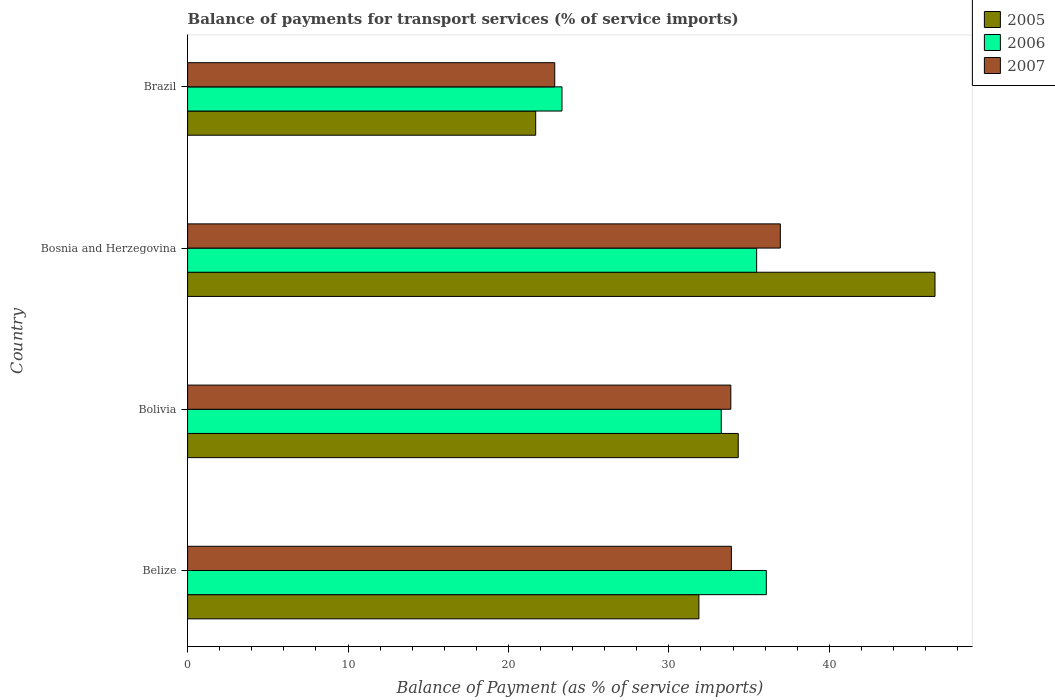How many different coloured bars are there?
Your answer should be compact. 3. Are the number of bars on each tick of the Y-axis equal?
Offer a terse response. Yes. In how many cases, is the number of bars for a given country not equal to the number of legend labels?
Provide a short and direct response. 0. What is the balance of payments for transport services in 2007 in Bosnia and Herzegovina?
Give a very brief answer. 36.95. Across all countries, what is the maximum balance of payments for transport services in 2006?
Ensure brevity in your answer.  36.07. Across all countries, what is the minimum balance of payments for transport services in 2006?
Your response must be concise. 23.34. In which country was the balance of payments for transport services in 2007 maximum?
Your response must be concise. Bosnia and Herzegovina. In which country was the balance of payments for transport services in 2005 minimum?
Offer a very short reply. Brazil. What is the total balance of payments for transport services in 2007 in the graph?
Keep it short and to the point. 127.59. What is the difference between the balance of payments for transport services in 2006 in Belize and that in Bolivia?
Give a very brief answer. 2.81. What is the difference between the balance of payments for transport services in 2007 in Bosnia and Herzegovina and the balance of payments for transport services in 2005 in Brazil?
Provide a short and direct response. 15.25. What is the average balance of payments for transport services in 2007 per country?
Provide a succinct answer. 31.9. What is the difference between the balance of payments for transport services in 2005 and balance of payments for transport services in 2006 in Belize?
Provide a short and direct response. -4.2. What is the ratio of the balance of payments for transport services in 2006 in Belize to that in Bosnia and Herzegovina?
Provide a succinct answer. 1.02. Is the balance of payments for transport services in 2005 in Bolivia less than that in Bosnia and Herzegovina?
Give a very brief answer. Yes. What is the difference between the highest and the second highest balance of payments for transport services in 2006?
Ensure brevity in your answer.  0.6. What is the difference between the highest and the lowest balance of payments for transport services in 2005?
Offer a terse response. 24.89. What does the 2nd bar from the bottom in Bosnia and Herzegovina represents?
Your answer should be very brief. 2006. Is it the case that in every country, the sum of the balance of payments for transport services in 2006 and balance of payments for transport services in 2005 is greater than the balance of payments for transport services in 2007?
Offer a terse response. Yes. How many bars are there?
Offer a terse response. 12. Are the values on the major ticks of X-axis written in scientific E-notation?
Keep it short and to the point. No. Where does the legend appear in the graph?
Make the answer very short. Top right. What is the title of the graph?
Give a very brief answer. Balance of payments for transport services (% of service imports). Does "2014" appear as one of the legend labels in the graph?
Provide a succinct answer. No. What is the label or title of the X-axis?
Offer a terse response. Balance of Payment (as % of service imports). What is the label or title of the Y-axis?
Give a very brief answer. Country. What is the Balance of Payment (as % of service imports) in 2005 in Belize?
Your answer should be compact. 31.87. What is the Balance of Payment (as % of service imports) in 2006 in Belize?
Your response must be concise. 36.07. What is the Balance of Payment (as % of service imports) of 2007 in Belize?
Your answer should be compact. 33.89. What is the Balance of Payment (as % of service imports) of 2005 in Bolivia?
Give a very brief answer. 34.32. What is the Balance of Payment (as % of service imports) in 2006 in Bolivia?
Offer a very short reply. 33.26. What is the Balance of Payment (as % of service imports) in 2007 in Bolivia?
Your response must be concise. 33.86. What is the Balance of Payment (as % of service imports) in 2005 in Bosnia and Herzegovina?
Your answer should be compact. 46.59. What is the Balance of Payment (as % of service imports) in 2006 in Bosnia and Herzegovina?
Your response must be concise. 35.47. What is the Balance of Payment (as % of service imports) in 2007 in Bosnia and Herzegovina?
Ensure brevity in your answer.  36.95. What is the Balance of Payment (as % of service imports) of 2005 in Brazil?
Your response must be concise. 21.7. What is the Balance of Payment (as % of service imports) of 2006 in Brazil?
Your answer should be very brief. 23.34. What is the Balance of Payment (as % of service imports) in 2007 in Brazil?
Make the answer very short. 22.89. Across all countries, what is the maximum Balance of Payment (as % of service imports) in 2005?
Provide a short and direct response. 46.59. Across all countries, what is the maximum Balance of Payment (as % of service imports) in 2006?
Your answer should be compact. 36.07. Across all countries, what is the maximum Balance of Payment (as % of service imports) in 2007?
Your response must be concise. 36.95. Across all countries, what is the minimum Balance of Payment (as % of service imports) of 2005?
Provide a short and direct response. 21.7. Across all countries, what is the minimum Balance of Payment (as % of service imports) in 2006?
Provide a succinct answer. 23.34. Across all countries, what is the minimum Balance of Payment (as % of service imports) of 2007?
Ensure brevity in your answer.  22.89. What is the total Balance of Payment (as % of service imports) in 2005 in the graph?
Your answer should be very brief. 134.48. What is the total Balance of Payment (as % of service imports) of 2006 in the graph?
Give a very brief answer. 128.14. What is the total Balance of Payment (as % of service imports) of 2007 in the graph?
Provide a succinct answer. 127.59. What is the difference between the Balance of Payment (as % of service imports) in 2005 in Belize and that in Bolivia?
Make the answer very short. -2.45. What is the difference between the Balance of Payment (as % of service imports) of 2006 in Belize and that in Bolivia?
Provide a short and direct response. 2.81. What is the difference between the Balance of Payment (as % of service imports) of 2007 in Belize and that in Bolivia?
Your response must be concise. 0.03. What is the difference between the Balance of Payment (as % of service imports) in 2005 in Belize and that in Bosnia and Herzegovina?
Ensure brevity in your answer.  -14.72. What is the difference between the Balance of Payment (as % of service imports) of 2006 in Belize and that in Bosnia and Herzegovina?
Provide a succinct answer. 0.6. What is the difference between the Balance of Payment (as % of service imports) in 2007 in Belize and that in Bosnia and Herzegovina?
Your answer should be compact. -3.05. What is the difference between the Balance of Payment (as % of service imports) in 2005 in Belize and that in Brazil?
Give a very brief answer. 10.17. What is the difference between the Balance of Payment (as % of service imports) in 2006 in Belize and that in Brazil?
Provide a short and direct response. 12.74. What is the difference between the Balance of Payment (as % of service imports) in 2007 in Belize and that in Brazil?
Keep it short and to the point. 11.01. What is the difference between the Balance of Payment (as % of service imports) in 2005 in Bolivia and that in Bosnia and Herzegovina?
Your answer should be very brief. -12.26. What is the difference between the Balance of Payment (as % of service imports) of 2006 in Bolivia and that in Bosnia and Herzegovina?
Keep it short and to the point. -2.21. What is the difference between the Balance of Payment (as % of service imports) of 2007 in Bolivia and that in Bosnia and Herzegovina?
Provide a short and direct response. -3.09. What is the difference between the Balance of Payment (as % of service imports) in 2005 in Bolivia and that in Brazil?
Offer a terse response. 12.63. What is the difference between the Balance of Payment (as % of service imports) of 2006 in Bolivia and that in Brazil?
Your response must be concise. 9.93. What is the difference between the Balance of Payment (as % of service imports) of 2007 in Bolivia and that in Brazil?
Your answer should be compact. 10.98. What is the difference between the Balance of Payment (as % of service imports) of 2005 in Bosnia and Herzegovina and that in Brazil?
Give a very brief answer. 24.89. What is the difference between the Balance of Payment (as % of service imports) of 2006 in Bosnia and Herzegovina and that in Brazil?
Provide a succinct answer. 12.13. What is the difference between the Balance of Payment (as % of service imports) in 2007 in Bosnia and Herzegovina and that in Brazil?
Offer a very short reply. 14.06. What is the difference between the Balance of Payment (as % of service imports) in 2005 in Belize and the Balance of Payment (as % of service imports) in 2006 in Bolivia?
Provide a succinct answer. -1.39. What is the difference between the Balance of Payment (as % of service imports) of 2005 in Belize and the Balance of Payment (as % of service imports) of 2007 in Bolivia?
Make the answer very short. -1.99. What is the difference between the Balance of Payment (as % of service imports) of 2006 in Belize and the Balance of Payment (as % of service imports) of 2007 in Bolivia?
Offer a very short reply. 2.21. What is the difference between the Balance of Payment (as % of service imports) of 2005 in Belize and the Balance of Payment (as % of service imports) of 2006 in Bosnia and Herzegovina?
Provide a succinct answer. -3.6. What is the difference between the Balance of Payment (as % of service imports) in 2005 in Belize and the Balance of Payment (as % of service imports) in 2007 in Bosnia and Herzegovina?
Your answer should be very brief. -5.08. What is the difference between the Balance of Payment (as % of service imports) of 2006 in Belize and the Balance of Payment (as % of service imports) of 2007 in Bosnia and Herzegovina?
Give a very brief answer. -0.87. What is the difference between the Balance of Payment (as % of service imports) of 2005 in Belize and the Balance of Payment (as % of service imports) of 2006 in Brazil?
Offer a very short reply. 8.53. What is the difference between the Balance of Payment (as % of service imports) of 2005 in Belize and the Balance of Payment (as % of service imports) of 2007 in Brazil?
Provide a succinct answer. 8.99. What is the difference between the Balance of Payment (as % of service imports) of 2006 in Belize and the Balance of Payment (as % of service imports) of 2007 in Brazil?
Provide a short and direct response. 13.19. What is the difference between the Balance of Payment (as % of service imports) in 2005 in Bolivia and the Balance of Payment (as % of service imports) in 2006 in Bosnia and Herzegovina?
Your answer should be very brief. -1.15. What is the difference between the Balance of Payment (as % of service imports) of 2005 in Bolivia and the Balance of Payment (as % of service imports) of 2007 in Bosnia and Herzegovina?
Provide a succinct answer. -2.62. What is the difference between the Balance of Payment (as % of service imports) in 2006 in Bolivia and the Balance of Payment (as % of service imports) in 2007 in Bosnia and Herzegovina?
Ensure brevity in your answer.  -3.68. What is the difference between the Balance of Payment (as % of service imports) in 2005 in Bolivia and the Balance of Payment (as % of service imports) in 2006 in Brazil?
Your response must be concise. 10.99. What is the difference between the Balance of Payment (as % of service imports) in 2005 in Bolivia and the Balance of Payment (as % of service imports) in 2007 in Brazil?
Make the answer very short. 11.44. What is the difference between the Balance of Payment (as % of service imports) of 2006 in Bolivia and the Balance of Payment (as % of service imports) of 2007 in Brazil?
Make the answer very short. 10.38. What is the difference between the Balance of Payment (as % of service imports) in 2005 in Bosnia and Herzegovina and the Balance of Payment (as % of service imports) in 2006 in Brazil?
Keep it short and to the point. 23.25. What is the difference between the Balance of Payment (as % of service imports) of 2005 in Bosnia and Herzegovina and the Balance of Payment (as % of service imports) of 2007 in Brazil?
Your answer should be compact. 23.7. What is the difference between the Balance of Payment (as % of service imports) in 2006 in Bosnia and Herzegovina and the Balance of Payment (as % of service imports) in 2007 in Brazil?
Provide a succinct answer. 12.58. What is the average Balance of Payment (as % of service imports) of 2005 per country?
Offer a very short reply. 33.62. What is the average Balance of Payment (as % of service imports) of 2006 per country?
Ensure brevity in your answer.  32.04. What is the average Balance of Payment (as % of service imports) in 2007 per country?
Your response must be concise. 31.9. What is the difference between the Balance of Payment (as % of service imports) in 2005 and Balance of Payment (as % of service imports) in 2006 in Belize?
Make the answer very short. -4.2. What is the difference between the Balance of Payment (as % of service imports) of 2005 and Balance of Payment (as % of service imports) of 2007 in Belize?
Offer a very short reply. -2.02. What is the difference between the Balance of Payment (as % of service imports) of 2006 and Balance of Payment (as % of service imports) of 2007 in Belize?
Provide a short and direct response. 2.18. What is the difference between the Balance of Payment (as % of service imports) in 2005 and Balance of Payment (as % of service imports) in 2006 in Bolivia?
Provide a short and direct response. 1.06. What is the difference between the Balance of Payment (as % of service imports) of 2005 and Balance of Payment (as % of service imports) of 2007 in Bolivia?
Ensure brevity in your answer.  0.46. What is the difference between the Balance of Payment (as % of service imports) of 2006 and Balance of Payment (as % of service imports) of 2007 in Bolivia?
Offer a very short reply. -0.6. What is the difference between the Balance of Payment (as % of service imports) of 2005 and Balance of Payment (as % of service imports) of 2006 in Bosnia and Herzegovina?
Your answer should be compact. 11.12. What is the difference between the Balance of Payment (as % of service imports) of 2005 and Balance of Payment (as % of service imports) of 2007 in Bosnia and Herzegovina?
Your answer should be very brief. 9.64. What is the difference between the Balance of Payment (as % of service imports) of 2006 and Balance of Payment (as % of service imports) of 2007 in Bosnia and Herzegovina?
Your answer should be very brief. -1.48. What is the difference between the Balance of Payment (as % of service imports) in 2005 and Balance of Payment (as % of service imports) in 2006 in Brazil?
Provide a succinct answer. -1.64. What is the difference between the Balance of Payment (as % of service imports) of 2005 and Balance of Payment (as % of service imports) of 2007 in Brazil?
Your response must be concise. -1.19. What is the difference between the Balance of Payment (as % of service imports) in 2006 and Balance of Payment (as % of service imports) in 2007 in Brazil?
Your answer should be compact. 0.45. What is the ratio of the Balance of Payment (as % of service imports) in 2005 in Belize to that in Bolivia?
Your answer should be compact. 0.93. What is the ratio of the Balance of Payment (as % of service imports) in 2006 in Belize to that in Bolivia?
Make the answer very short. 1.08. What is the ratio of the Balance of Payment (as % of service imports) in 2007 in Belize to that in Bolivia?
Offer a terse response. 1. What is the ratio of the Balance of Payment (as % of service imports) of 2005 in Belize to that in Bosnia and Herzegovina?
Your answer should be very brief. 0.68. What is the ratio of the Balance of Payment (as % of service imports) of 2007 in Belize to that in Bosnia and Herzegovina?
Provide a succinct answer. 0.92. What is the ratio of the Balance of Payment (as % of service imports) of 2005 in Belize to that in Brazil?
Offer a very short reply. 1.47. What is the ratio of the Balance of Payment (as % of service imports) in 2006 in Belize to that in Brazil?
Keep it short and to the point. 1.55. What is the ratio of the Balance of Payment (as % of service imports) of 2007 in Belize to that in Brazil?
Your response must be concise. 1.48. What is the ratio of the Balance of Payment (as % of service imports) of 2005 in Bolivia to that in Bosnia and Herzegovina?
Ensure brevity in your answer.  0.74. What is the ratio of the Balance of Payment (as % of service imports) in 2006 in Bolivia to that in Bosnia and Herzegovina?
Give a very brief answer. 0.94. What is the ratio of the Balance of Payment (as % of service imports) of 2007 in Bolivia to that in Bosnia and Herzegovina?
Offer a very short reply. 0.92. What is the ratio of the Balance of Payment (as % of service imports) in 2005 in Bolivia to that in Brazil?
Keep it short and to the point. 1.58. What is the ratio of the Balance of Payment (as % of service imports) of 2006 in Bolivia to that in Brazil?
Ensure brevity in your answer.  1.43. What is the ratio of the Balance of Payment (as % of service imports) in 2007 in Bolivia to that in Brazil?
Keep it short and to the point. 1.48. What is the ratio of the Balance of Payment (as % of service imports) of 2005 in Bosnia and Herzegovina to that in Brazil?
Provide a short and direct response. 2.15. What is the ratio of the Balance of Payment (as % of service imports) of 2006 in Bosnia and Herzegovina to that in Brazil?
Ensure brevity in your answer.  1.52. What is the ratio of the Balance of Payment (as % of service imports) of 2007 in Bosnia and Herzegovina to that in Brazil?
Your response must be concise. 1.61. What is the difference between the highest and the second highest Balance of Payment (as % of service imports) in 2005?
Make the answer very short. 12.26. What is the difference between the highest and the second highest Balance of Payment (as % of service imports) in 2006?
Give a very brief answer. 0.6. What is the difference between the highest and the second highest Balance of Payment (as % of service imports) of 2007?
Ensure brevity in your answer.  3.05. What is the difference between the highest and the lowest Balance of Payment (as % of service imports) of 2005?
Your answer should be compact. 24.89. What is the difference between the highest and the lowest Balance of Payment (as % of service imports) of 2006?
Give a very brief answer. 12.74. What is the difference between the highest and the lowest Balance of Payment (as % of service imports) of 2007?
Keep it short and to the point. 14.06. 